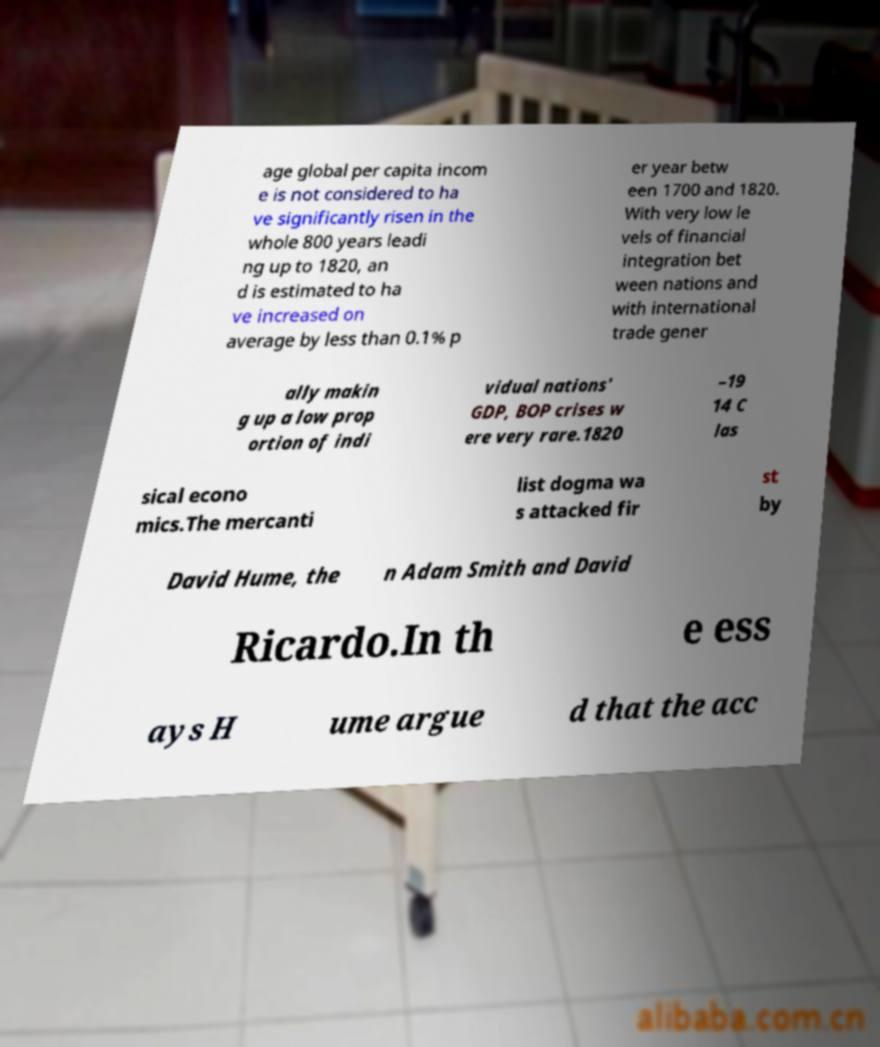What messages or text are displayed in this image? I need them in a readable, typed format. age global per capita incom e is not considered to ha ve significantly risen in the whole 800 years leadi ng up to 1820, an d is estimated to ha ve increased on average by less than 0.1% p er year betw een 1700 and 1820. With very low le vels of financial integration bet ween nations and with international trade gener ally makin g up a low prop ortion of indi vidual nations' GDP, BOP crises w ere very rare.1820 –19 14 C las sical econo mics.The mercanti list dogma wa s attacked fir st by David Hume, the n Adam Smith and David Ricardo.In th e ess ays H ume argue d that the acc 